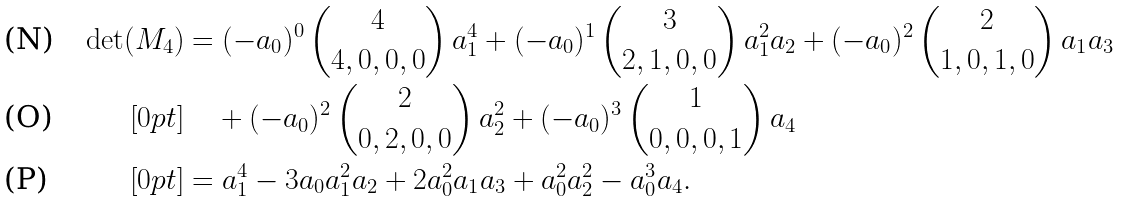Convert formula to latex. <formula><loc_0><loc_0><loc_500><loc_500>\det ( M _ { 4 } ) & = ( - a _ { 0 } ) ^ { 0 } \, { 4 \choose 4 , 0 , 0 , 0 } \, a _ { 1 } ^ { 4 } + ( - a _ { 0 } ) ^ { 1 } \, { 3 \choose 2 , 1 , 0 , 0 } \, a _ { 1 } ^ { 2 } a _ { 2 } + ( - a _ { 0 } ) ^ { 2 } \, { 2 \choose 1 , 0 , 1 , 0 } \, a _ { 1 } a _ { 3 } \\ [ 0 p t ] & \quad + ( - a _ { 0 } ) ^ { 2 } \, { 2 \choose 0 , 2 , 0 , 0 } \, a _ { 2 } ^ { 2 } + ( - a _ { 0 } ) ^ { 3 } \, { 1 \choose 0 , 0 , 0 , 1 } \, a _ { 4 } \\ [ 0 p t ] & = a _ { 1 } ^ { 4 } - 3 a _ { 0 } a _ { 1 } ^ { 2 } a _ { 2 } + 2 a _ { 0 } ^ { 2 } a _ { 1 } a _ { 3 } + a _ { 0 } ^ { 2 } a _ { 2 } ^ { 2 } - a _ { 0 } ^ { 3 } a _ { 4 } .</formula> 